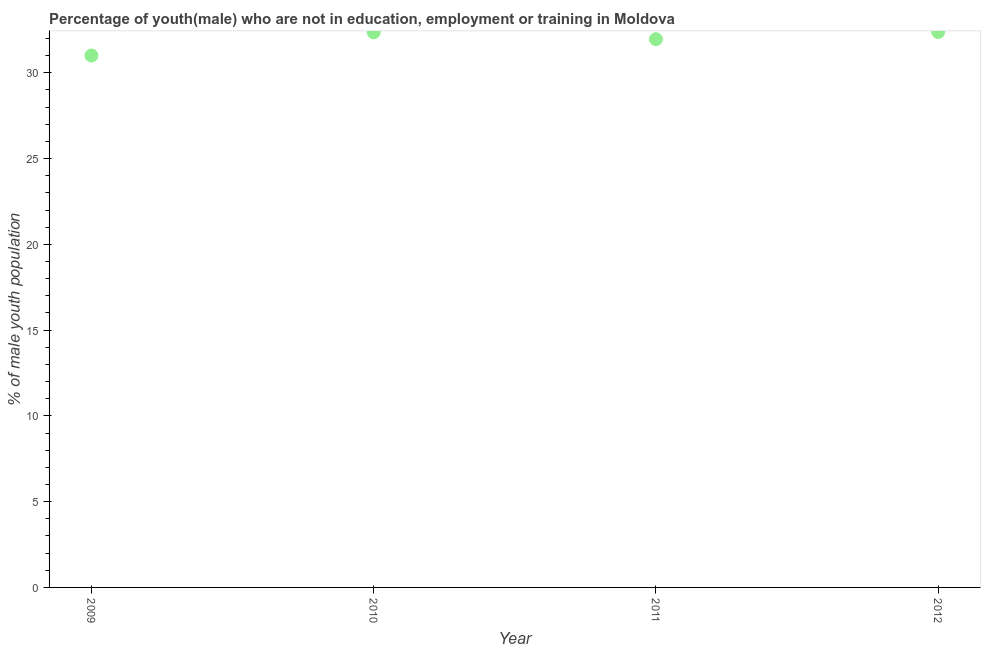What is the unemployed male youth population in 2009?
Offer a terse response. 31.01. Across all years, what is the maximum unemployed male youth population?
Offer a terse response. 32.38. Across all years, what is the minimum unemployed male youth population?
Keep it short and to the point. 31.01. What is the sum of the unemployed male youth population?
Offer a very short reply. 127.71. What is the difference between the unemployed male youth population in 2009 and 2011?
Your response must be concise. -0.95. What is the average unemployed male youth population per year?
Offer a terse response. 31.93. What is the median unemployed male youth population?
Keep it short and to the point. 32.16. In how many years, is the unemployed male youth population greater than 1 %?
Give a very brief answer. 4. What is the ratio of the unemployed male youth population in 2009 to that in 2011?
Provide a succinct answer. 0.97. What is the difference between the highest and the second highest unemployed male youth population?
Make the answer very short. 0.02. Is the sum of the unemployed male youth population in 2009 and 2010 greater than the maximum unemployed male youth population across all years?
Keep it short and to the point. Yes. What is the difference between the highest and the lowest unemployed male youth population?
Offer a terse response. 1.37. In how many years, is the unemployed male youth population greater than the average unemployed male youth population taken over all years?
Keep it short and to the point. 3. Does the unemployed male youth population monotonically increase over the years?
Your response must be concise. No. What is the title of the graph?
Provide a succinct answer. Percentage of youth(male) who are not in education, employment or training in Moldova. What is the label or title of the Y-axis?
Offer a terse response. % of male youth population. What is the % of male youth population in 2009?
Provide a short and direct response. 31.01. What is the % of male youth population in 2010?
Keep it short and to the point. 32.36. What is the % of male youth population in 2011?
Ensure brevity in your answer.  31.96. What is the % of male youth population in 2012?
Offer a terse response. 32.38. What is the difference between the % of male youth population in 2009 and 2010?
Provide a short and direct response. -1.35. What is the difference between the % of male youth population in 2009 and 2011?
Keep it short and to the point. -0.95. What is the difference between the % of male youth population in 2009 and 2012?
Your response must be concise. -1.37. What is the difference between the % of male youth population in 2010 and 2011?
Offer a very short reply. 0.4. What is the difference between the % of male youth population in 2010 and 2012?
Offer a terse response. -0.02. What is the difference between the % of male youth population in 2011 and 2012?
Give a very brief answer. -0.42. What is the ratio of the % of male youth population in 2009 to that in 2010?
Offer a very short reply. 0.96. What is the ratio of the % of male youth population in 2009 to that in 2011?
Give a very brief answer. 0.97. What is the ratio of the % of male youth population in 2009 to that in 2012?
Offer a terse response. 0.96. What is the ratio of the % of male youth population in 2010 to that in 2011?
Your response must be concise. 1.01. What is the ratio of the % of male youth population in 2011 to that in 2012?
Offer a terse response. 0.99. 